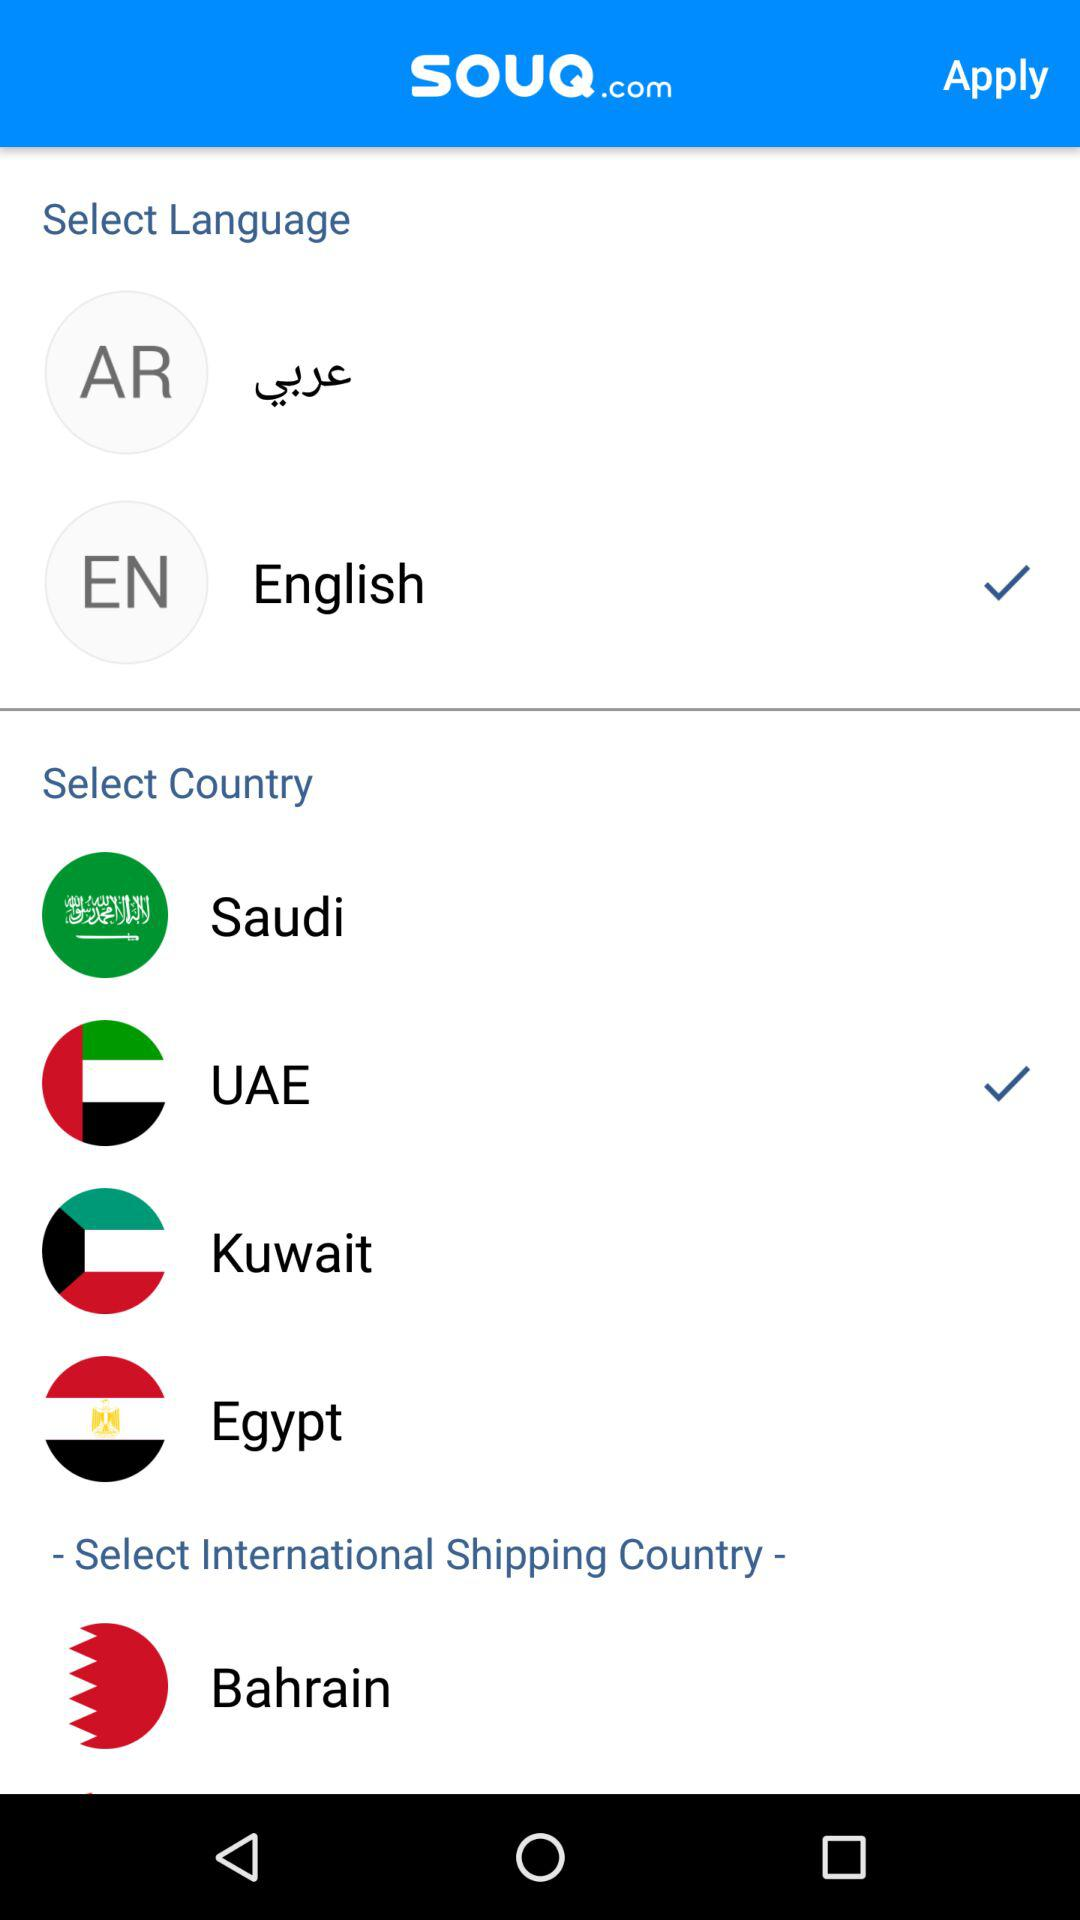Which country is shown under the category "Select International Shipping Country"? The country shown under the category "Select International Shipping Country" is Bahrain. 